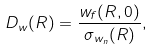Convert formula to latex. <formula><loc_0><loc_0><loc_500><loc_500>D _ { w } ( R ) = \frac { w _ { f } ( R , 0 ) } { \sigma _ { w _ { n } } ( R ) } ,</formula> 